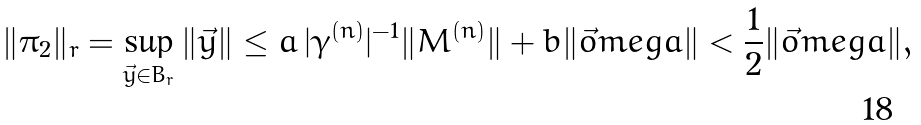<formula> <loc_0><loc_0><loc_500><loc_500>\| \pi _ { 2 } \| _ { r } = \sup _ { \vec { y } \in B _ { r } } \| \vec { y } \| \leq a \, | \gamma ^ { ( n ) } | ^ { - 1 } \| M ^ { ( n ) } \| + b \| \vec { o } m e g a \| < \frac { 1 } { 2 } \| \vec { o } m e g a \| ,</formula> 